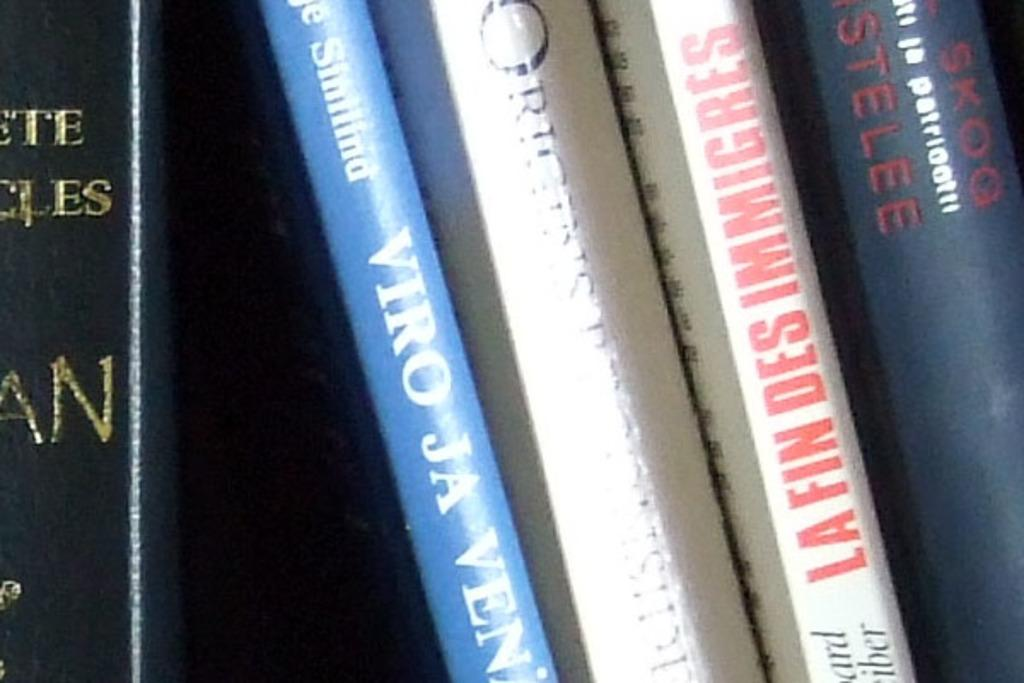<image>
Relay a brief, clear account of the picture shown. books on a shelf one called  Viro Ja Veni 